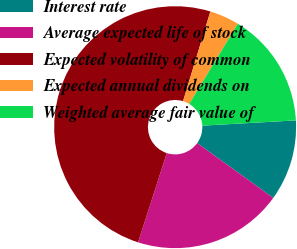Convert chart. <chart><loc_0><loc_0><loc_500><loc_500><pie_chart><fcel>Interest rate<fcel>Average expected life of stock<fcel>Expected volatility of common<fcel>Expected annual dividends on<fcel>Weighted average fair value of<nl><fcel>10.84%<fcel>20.01%<fcel>49.75%<fcel>3.97%<fcel>15.43%<nl></chart> 